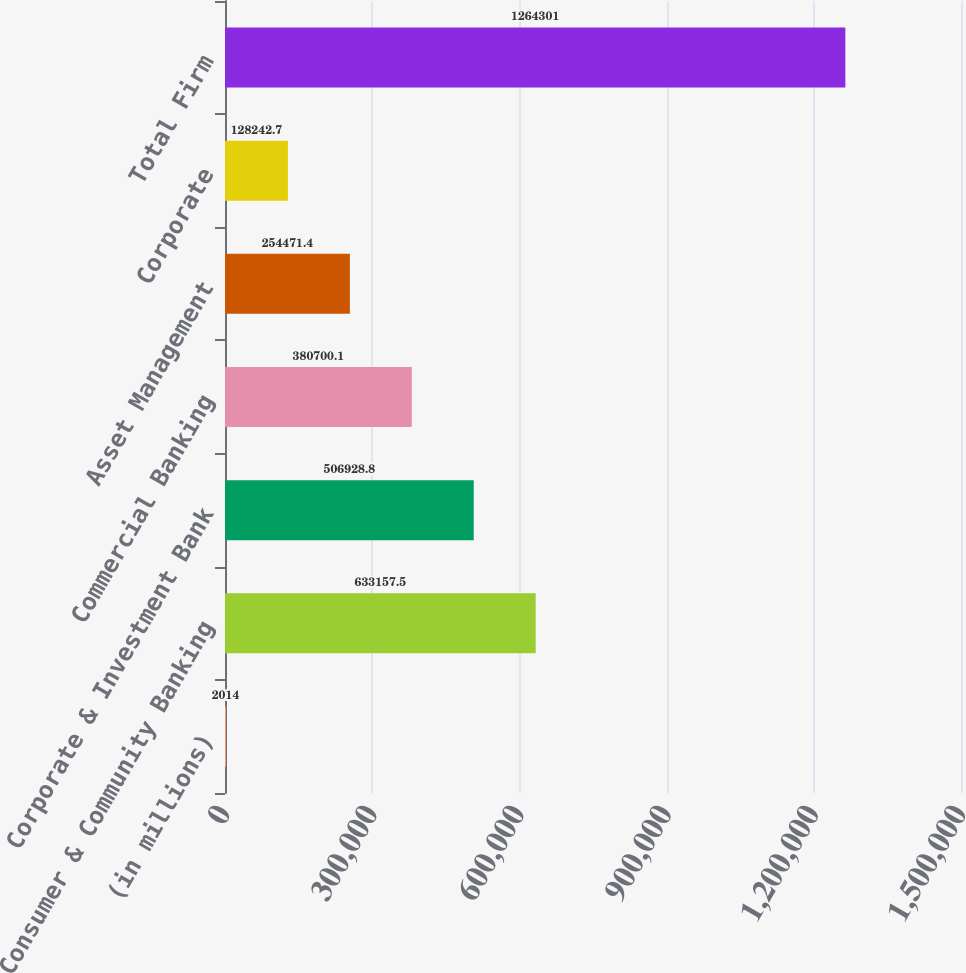Convert chart to OTSL. <chart><loc_0><loc_0><loc_500><loc_500><bar_chart><fcel>(in millions)<fcel>Consumer & Community Banking<fcel>Corporate & Investment Bank<fcel>Commercial Banking<fcel>Asset Management<fcel>Corporate<fcel>Total Firm<nl><fcel>2014<fcel>633158<fcel>506929<fcel>380700<fcel>254471<fcel>128243<fcel>1.2643e+06<nl></chart> 